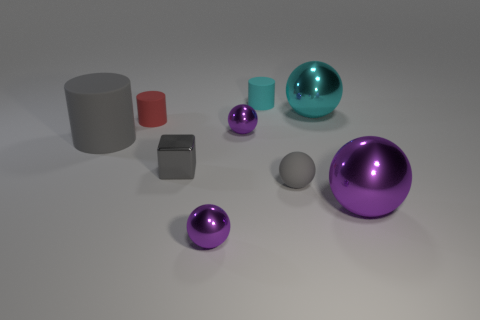Subtract all small matte cylinders. How many cylinders are left? 1 Subtract all cyan cylinders. How many cylinders are left? 2 Subtract all cubes. How many objects are left? 8 Add 1 small cyan rubber things. How many objects exist? 10 Subtract 1 cubes. How many cubes are left? 0 Subtract all purple blocks. Subtract all green spheres. How many blocks are left? 1 Subtract all blue cubes. How many blue cylinders are left? 0 Subtract all large blue matte cubes. Subtract all tiny cyan matte cylinders. How many objects are left? 8 Add 8 big cyan shiny things. How many big cyan shiny things are left? 9 Add 8 small purple metal things. How many small purple metal things exist? 10 